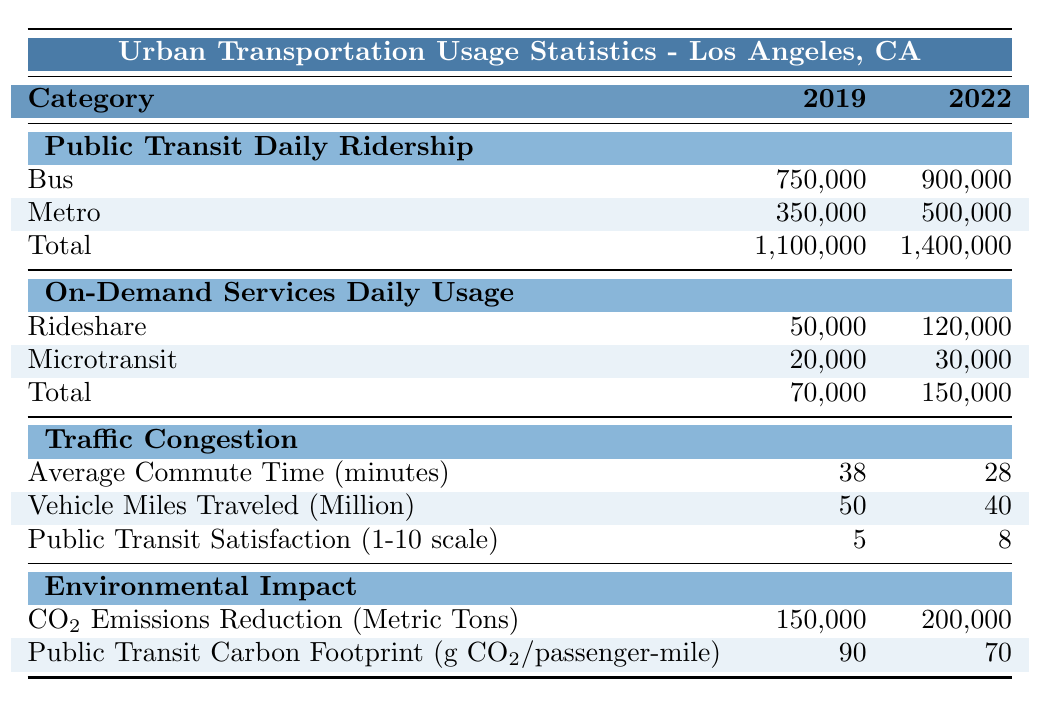What was the total daily ridership for public transit in 2019? The total daily ridership for public transit is specified directly in the table under the "Total" row for the year 2019, which is 1,100,000.
Answer: 1,100,000 What is the average commute time before the implementation of smart transit solutions? The average commute time before implementation is found under the "Traffic Congestion" section for the year 2019, which is 38 minutes.
Answer: 38 minutes How many more rideshare usages were there per day after the smart transit solutions were implemented compared to before? To find the difference, subtract the daily rideshare usage before implementation (50,000) from after implementation (120,000): 120,000 - 50,000 = 70,000.
Answer: 70,000 Did the public transit satisfaction rating increase after the implementation of smart transit solutions? By comparing the public transit satisfaction ratings before and after (5 in 2019 and 8 in 2022), it is clear that the rating increased.
Answer: Yes What was the decrease in vehicle miles traveled after the implementation? The decrease in vehicle miles traveled is calculated by subtracting the 2022 figure (40 million) from the 2019 figure (50 million): 50 - 40 = 10 million.
Answer: 10 million What was the percentage change in total public transit daily ridership from 2019 to 2022? The percentage change can be calculated using the formula: ((1400000 - 1100000) / 1100000) × 100 = (300000 / 1100000) × 100 ≈ 27.27%.
Answer: Approximately 27.27% Was there a reduction in CO2 emissions after the implementation? Comparing the CO2 emissions reduction figures, it shows that emissions increased from 150,000 metric tons to 200,000 metric tons, indicating a reduction in emissions.
Answer: Yes By how much did the public transit carbon footprint change from before to after the implementation? The change in the carbon footprint can be determined by subtracting the after value (70 g CO2/passenger-mile) from the before value (90 g CO2/passenger-mile): 90 - 70 = 20.
Answer: 20 g CO2/passenger-mile What is the total increase in daily usage for all on-demand services after implementation? The total daily usage for on-demand services after implementation is 150,000, and before was 70,000, so the increase is 150,000 - 70,000 = 80,000.
Answer: 80,000 How many total metric tons of CO2 emissions were avoided after the implementation? The emissions reduction saw an increase from 150,000 metric tons (before) to 200,000 metric tons (after), indicating an increase rather than avoidance. Therefore, the result is an increase of 50,000 metric tons and not avoided emissions.
Answer: 50,000 metric tons increase 